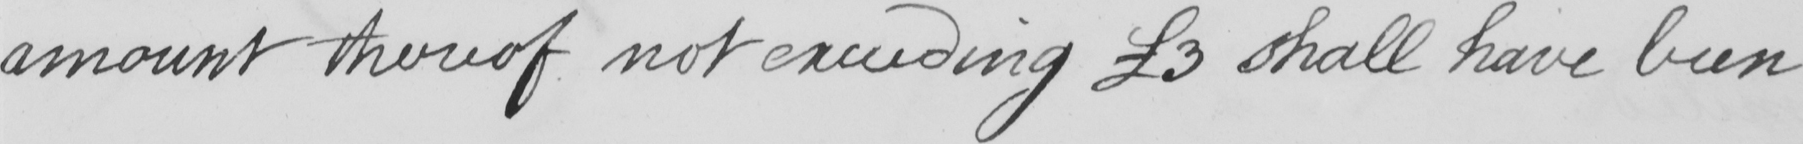Please provide the text content of this handwritten line. amount thereof not exceeding  £3 shall have been 